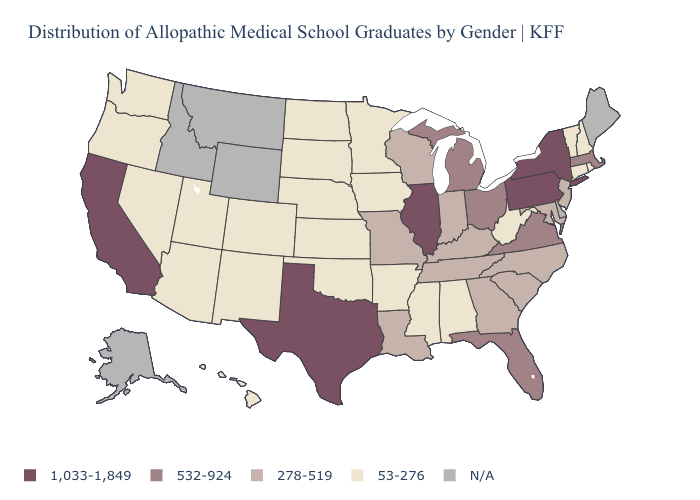What is the value of Alaska?
Write a very short answer. N/A. What is the value of Wisconsin?
Write a very short answer. 278-519. Which states hav the highest value in the Northeast?
Be succinct. New York, Pennsylvania. What is the highest value in the USA?
Write a very short answer. 1,033-1,849. What is the value of Delaware?
Answer briefly. N/A. Name the states that have a value in the range 278-519?
Answer briefly. Georgia, Indiana, Kentucky, Louisiana, Maryland, Missouri, New Jersey, North Carolina, South Carolina, Tennessee, Wisconsin. What is the value of New Mexico?
Give a very brief answer. 53-276. How many symbols are there in the legend?
Give a very brief answer. 5. What is the value of Vermont?
Give a very brief answer. 53-276. What is the value of South Dakota?
Concise answer only. 53-276. Name the states that have a value in the range N/A?
Give a very brief answer. Alaska, Delaware, Idaho, Maine, Montana, Wyoming. What is the value of South Carolina?
Give a very brief answer. 278-519. Does Pennsylvania have the lowest value in the Northeast?
Keep it brief. No. Name the states that have a value in the range N/A?
Give a very brief answer. Alaska, Delaware, Idaho, Maine, Montana, Wyoming. What is the value of Georgia?
Keep it brief. 278-519. 